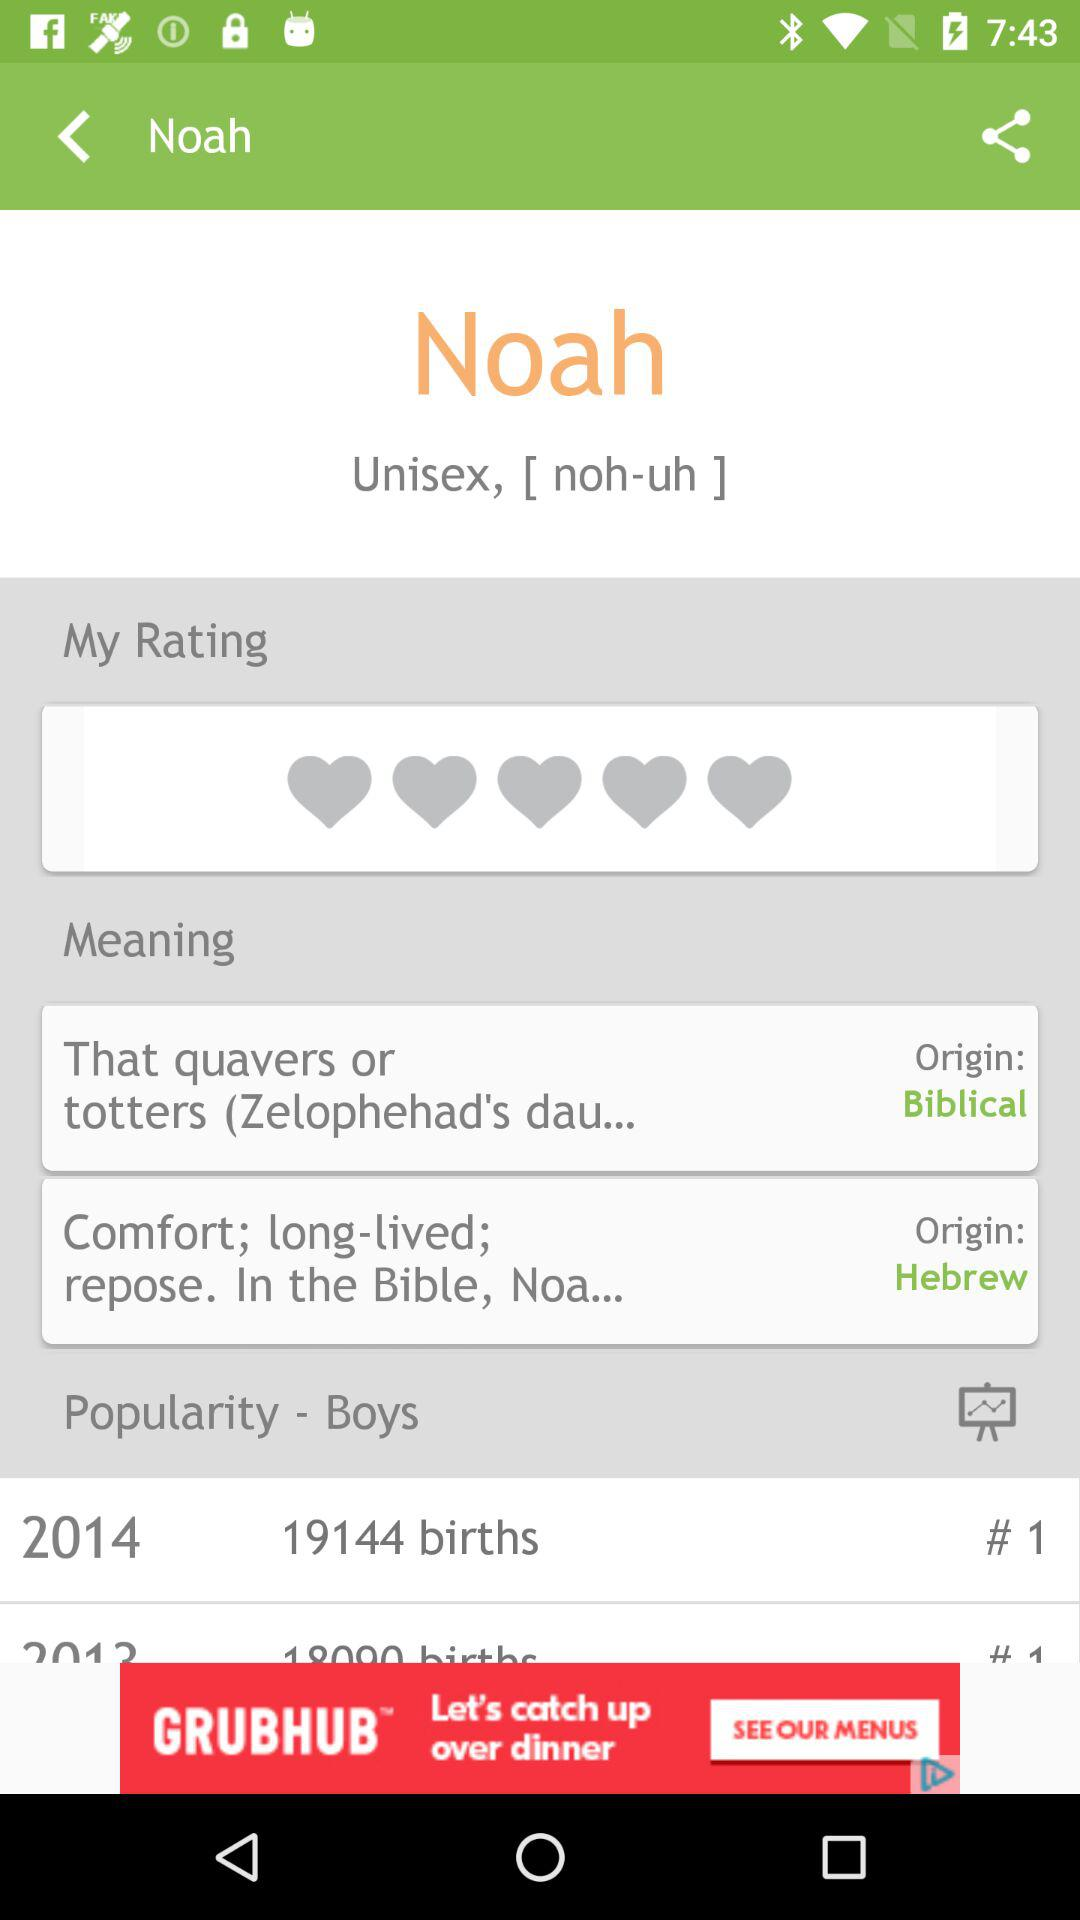What is the meaning of Noah's name? The meaning of Noah's name is "That quavers or totters (Zelophehad's dau...". 